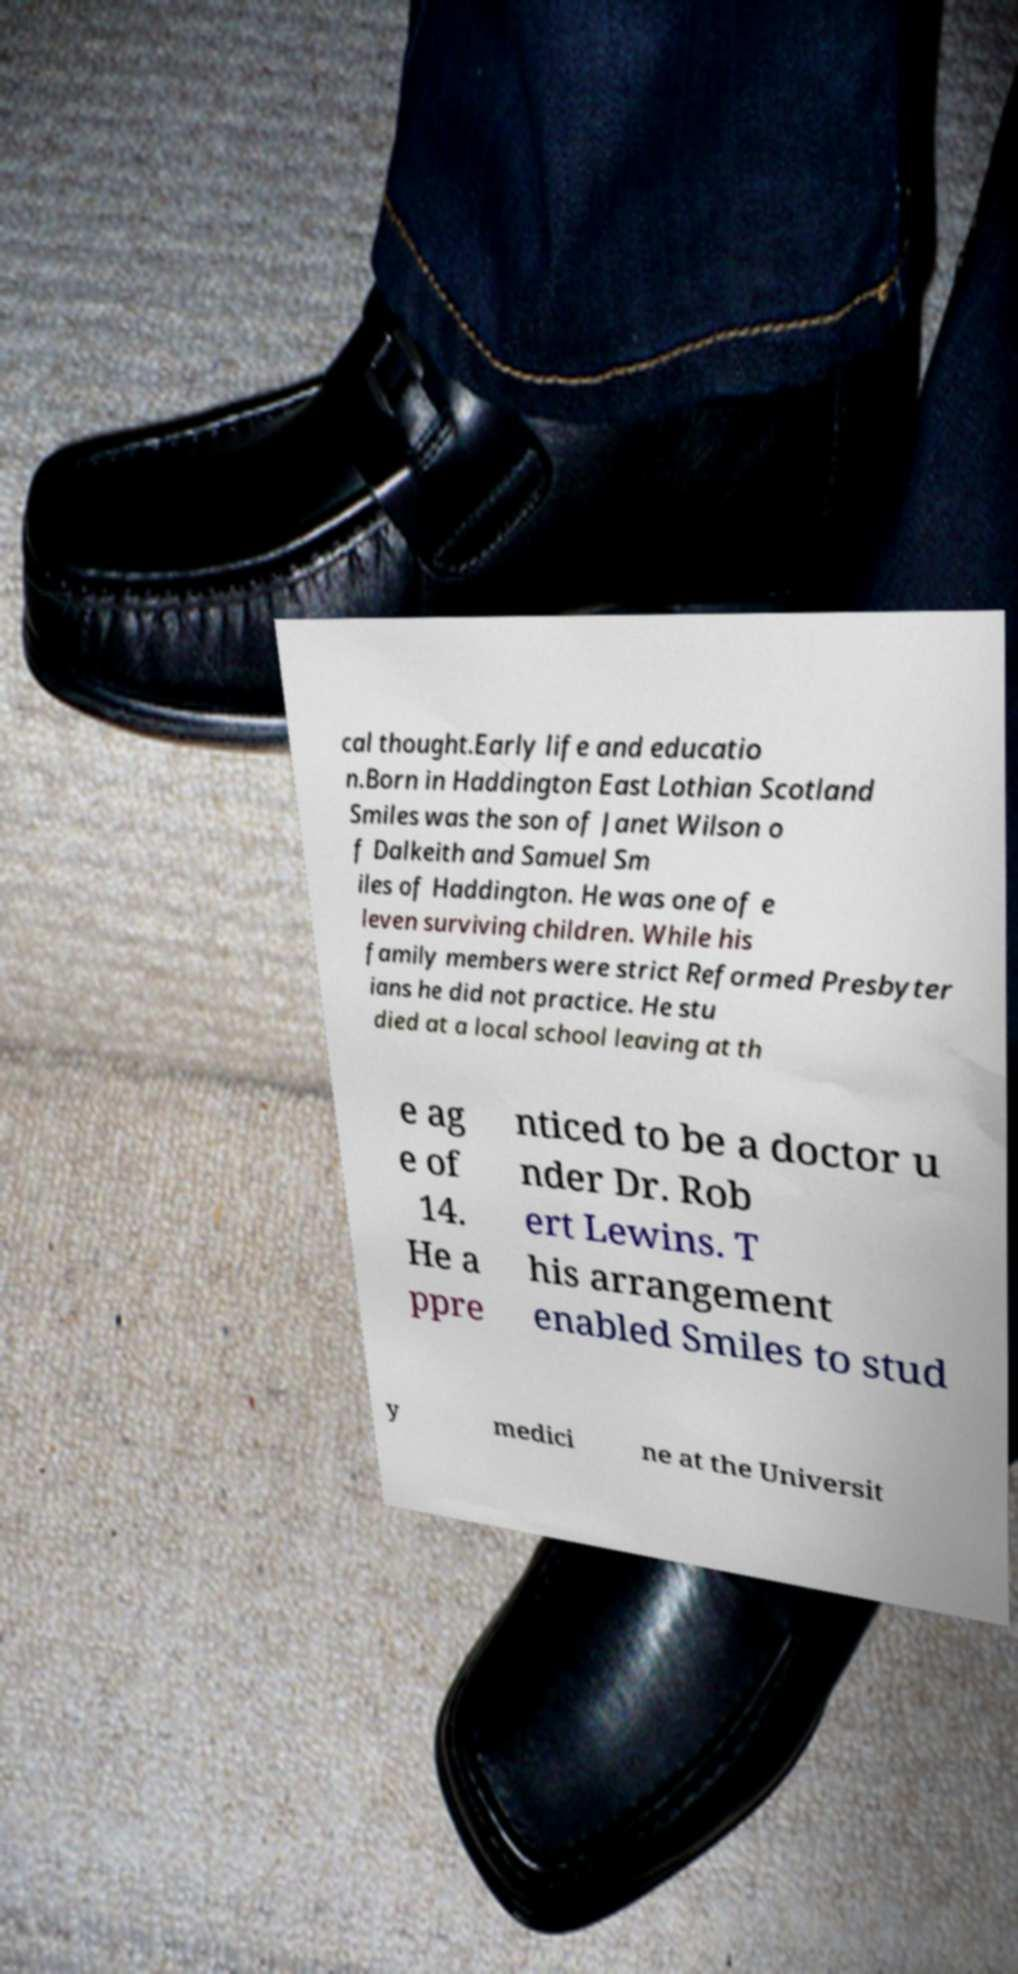Can you accurately transcribe the text from the provided image for me? cal thought.Early life and educatio n.Born in Haddington East Lothian Scotland Smiles was the son of Janet Wilson o f Dalkeith and Samuel Sm iles of Haddington. He was one of e leven surviving children. While his family members were strict Reformed Presbyter ians he did not practice. He stu died at a local school leaving at th e ag e of 14. He a ppre nticed to be a doctor u nder Dr. Rob ert Lewins. T his arrangement enabled Smiles to stud y medici ne at the Universit 